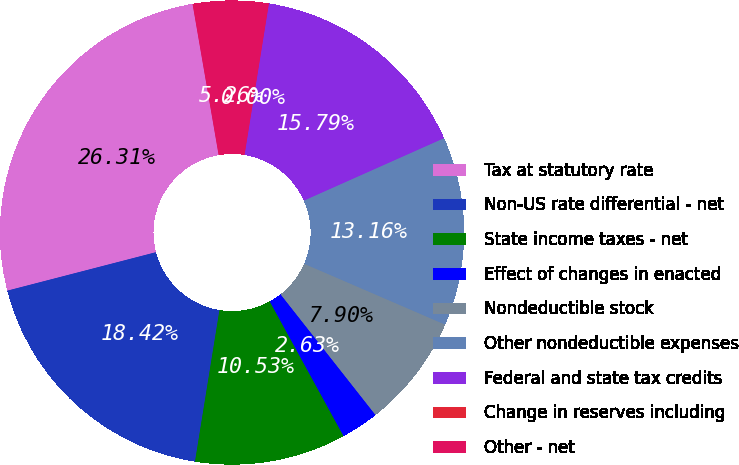<chart> <loc_0><loc_0><loc_500><loc_500><pie_chart><fcel>Tax at statutory rate<fcel>Non-US rate differential - net<fcel>State income taxes - net<fcel>Effect of changes in enacted<fcel>Nondeductible stock<fcel>Other nondeductible expenses<fcel>Federal and state tax credits<fcel>Change in reserves including<fcel>Other - net<nl><fcel>26.31%<fcel>18.42%<fcel>10.53%<fcel>2.63%<fcel>7.9%<fcel>13.16%<fcel>15.79%<fcel>0.0%<fcel>5.26%<nl></chart> 